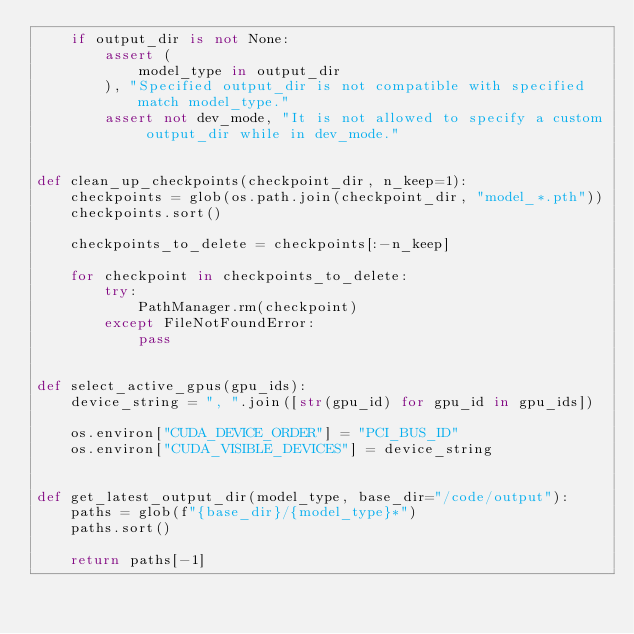Convert code to text. <code><loc_0><loc_0><loc_500><loc_500><_Python_>    if output_dir is not None:
        assert (
            model_type in output_dir
        ), "Specified output_dir is not compatible with specified match model_type."
        assert not dev_mode, "It is not allowed to specify a custom output_dir while in dev_mode."


def clean_up_checkpoints(checkpoint_dir, n_keep=1):
    checkpoints = glob(os.path.join(checkpoint_dir, "model_*.pth"))
    checkpoints.sort()

    checkpoints_to_delete = checkpoints[:-n_keep]

    for checkpoint in checkpoints_to_delete:
        try:
            PathManager.rm(checkpoint)
        except FileNotFoundError:
            pass


def select_active_gpus(gpu_ids):
    device_string = ", ".join([str(gpu_id) for gpu_id in gpu_ids])

    os.environ["CUDA_DEVICE_ORDER"] = "PCI_BUS_ID"
    os.environ["CUDA_VISIBLE_DEVICES"] = device_string


def get_latest_output_dir(model_type, base_dir="/code/output"):
    paths = glob(f"{base_dir}/{model_type}*")
    paths.sort()

    return paths[-1]
</code> 